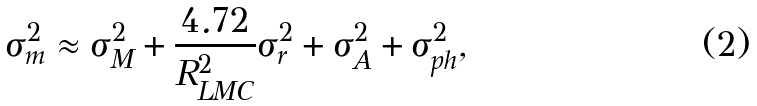<formula> <loc_0><loc_0><loc_500><loc_500>\sigma _ { m } ^ { 2 } \approx \sigma _ { M } ^ { 2 } + \frac { 4 . 7 2 } { R _ { L M C } ^ { 2 } } \sigma _ { r } ^ { 2 } + \sigma _ { A } ^ { 2 } + \sigma _ { p h } ^ { 2 } ,</formula> 